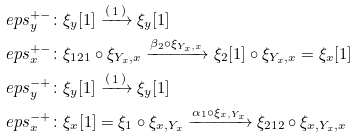<formula> <loc_0><loc_0><loc_500><loc_500>& \ e p s ^ { + - } _ { y } \colon \xi _ { y } [ 1 ] \xrightarrow { \left ( \begin{smallmatrix} 1 \end{smallmatrix} \right ) } \xi _ { y } [ 1 ] \\ & \ e p s ^ { + - } _ { x } \colon \xi _ { 1 2 1 } \circ \xi _ { Y _ { x } , x } \xrightarrow { \beta _ { 2 } \circ \xi _ { Y _ { x } , x } } \xi _ { 2 } [ 1 ] \circ \xi _ { Y _ { x } , x } = \xi _ { x } [ 1 ] \\ & \ e p s ^ { - + } _ { y } \colon \xi _ { y } [ 1 ] \xrightarrow { \left ( \begin{smallmatrix} 1 \end{smallmatrix} \right ) } \xi _ { y } [ 1 ] \\ & \ e p s ^ { - + } _ { x } \colon \xi _ { x } [ 1 ] = \xi _ { 1 } \circ \xi _ { x , Y _ { x } } \xrightarrow { \alpha _ { 1 } \circ \xi _ { x , Y _ { x } } } \xi _ { 2 1 2 } \circ \xi _ { x , Y _ { x } , x }</formula> 